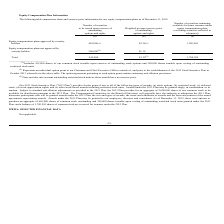According to Network 1 Technologies's financial document, Who would have benefited from the equity compensation plans not approved by security holders? Chairman and Chief Executive Officer. The document states: "(2) Represents an individual option grant to our Chairman and Chief Executive Officer outside of, and prior to the establishment of, the 2013 Stock In..." Also, Which parties may be granted Awards under the 2013 plan? Awards under the 2013 Plan may be granted to our employees, directors and consultants.. The document states: "ntent of the award agreements representing awards. Awards under the 2013 Plan may be granted to our employees, directors and consultants. As of Decemb..." Also, What are the types of awards that may be granted under the 2013 Stock Incentive Plan? (a) stock options, (b) restricted stock, (c) deferred stock, (d) stock appreciation rights, and (e) other stock-based awards including restricted stock units.. The document states: "nt of any or all of the following types of awards: (a) stock options, (b) restricted stock, (c) deferred stock, (d) stock appreciation rights, and (e)..." Also, can you calculate: What is the proportion of equity compensation plans approved by security holders to the total number of securities to be issued upon exercise of outstanding options and rights? Based on the calculation: 445,000/945,000, the result is 0.47. This is based on the information: "Total 945,000 $1.39 (3) 1,780,505 holders 445,000 (1) $2.34 (3) 1,780,505..." The key data points involved are: 445,000, 945,000. Also, can you calculate: What % of equity compensation plans that are approved are shares of common stock issuable upon exercise of outstanding stock options? Based on the calculation: 105,000/445,000, the result is 23.6 (percentage). This is based on the information: "holders 445,000 (1) $2.34 (3) 1,780,505 (1) Includes 105,000 shares of our common stock issuable upon exercise of outstanding stock options and 340,000 shares i..." The key data points involved are: 105,000, 445,000. Also, can you calculate: What % of equity compensation plans that are approved are shares issuable upon vesting of outstanding restricted stock units? Based on the calculation: 340,000/445,000, the result is 76.4 (percentage). This is based on the information: "holders 445,000 (1) $2.34 (3) 1,780,505 le upon exercise of outstanding stock options and 340,000 shares issuable upon vesting of outstanding..." The key data points involved are: 340,000, 445,000. 